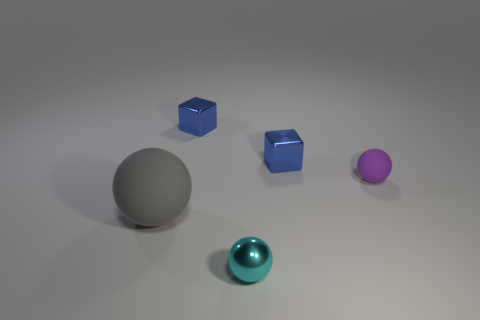Add 3 gray objects. How many objects exist? 8 Subtract all balls. How many objects are left? 2 Subtract all small objects. Subtract all small cyan matte balls. How many objects are left? 1 Add 4 big gray spheres. How many big gray spheres are left? 5 Add 5 brown rubber cylinders. How many brown rubber cylinders exist? 5 Subtract 1 cyan balls. How many objects are left? 4 